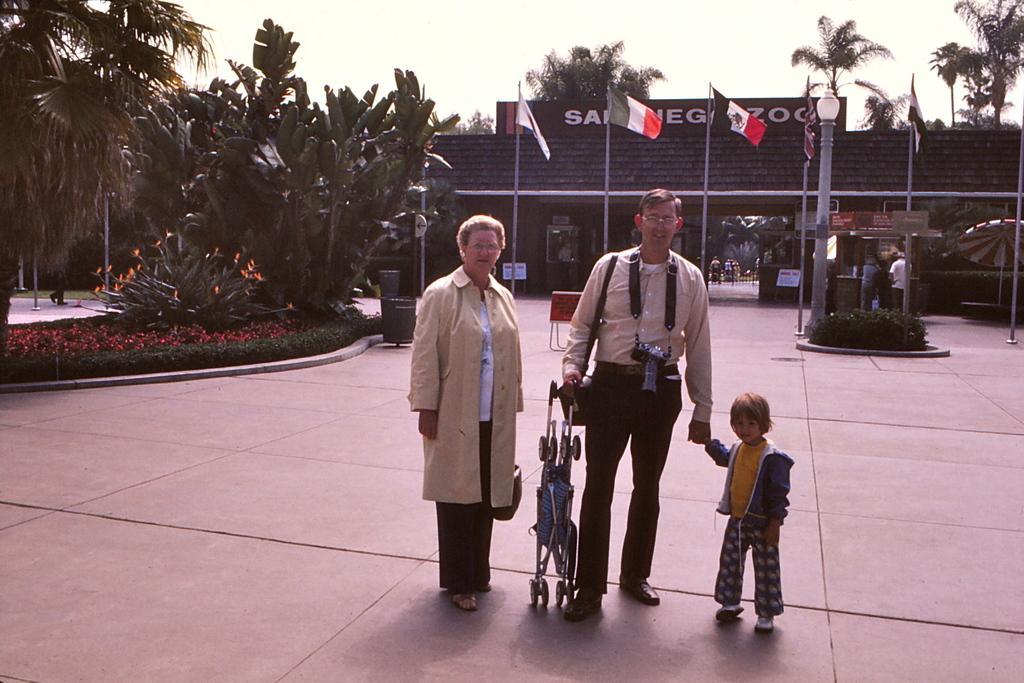Can you describe this image briefly? In this image, we can see women, men and kid are standing at the platform. Here we can see a person is holding a wheel chair. Background we can see wall, few boards, flags with poles, trees, plants. Top of the image, there is a sky. 